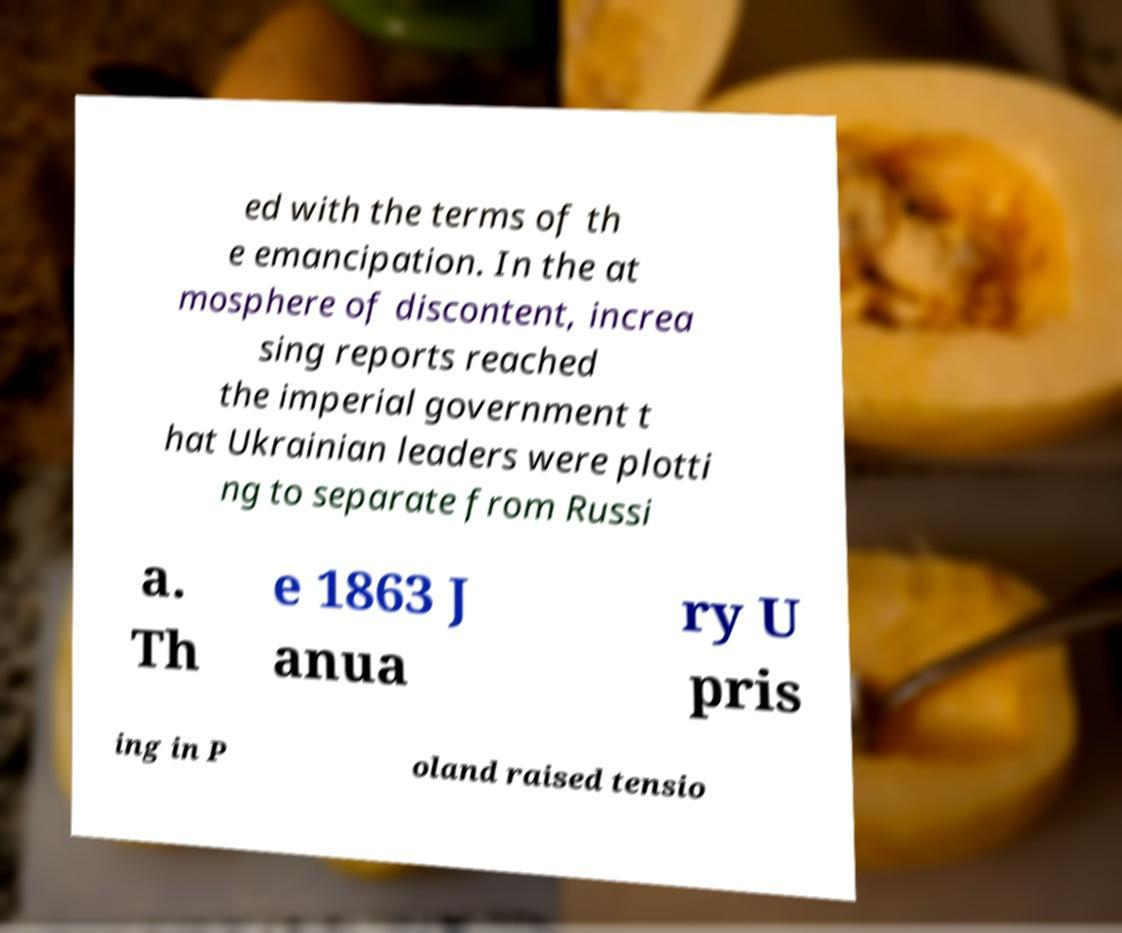Please identify and transcribe the text found in this image. ed with the terms of th e emancipation. In the at mosphere of discontent, increa sing reports reached the imperial government t hat Ukrainian leaders were plotti ng to separate from Russi a. Th e 1863 J anua ry U pris ing in P oland raised tensio 